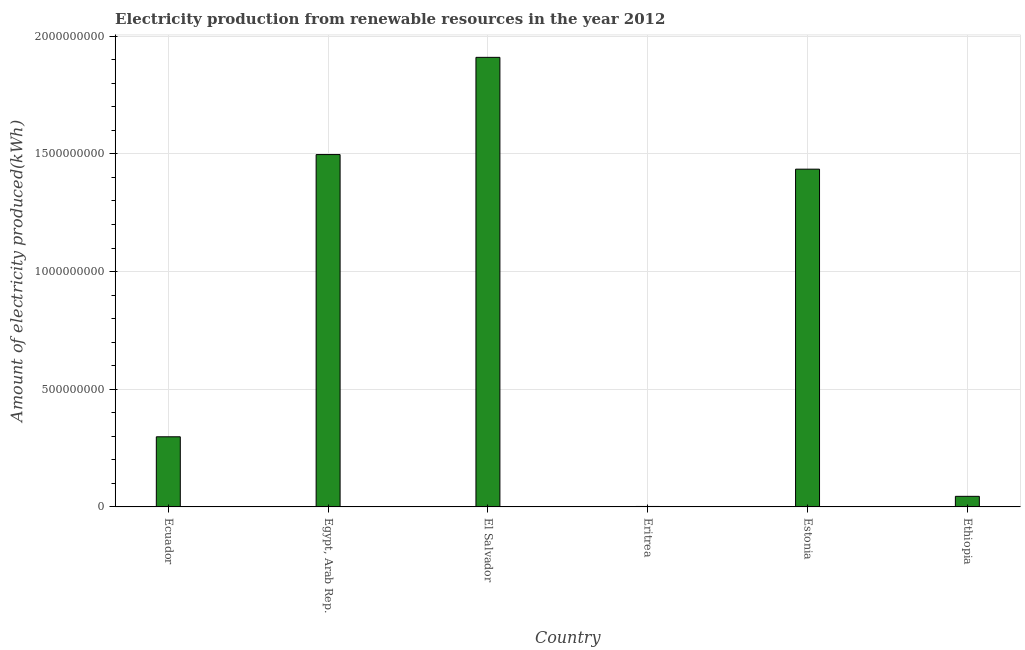Does the graph contain any zero values?
Make the answer very short. No. What is the title of the graph?
Ensure brevity in your answer.  Electricity production from renewable resources in the year 2012. What is the label or title of the Y-axis?
Ensure brevity in your answer.  Amount of electricity produced(kWh). What is the amount of electricity produced in Egypt, Arab Rep.?
Offer a terse response. 1.50e+09. Across all countries, what is the maximum amount of electricity produced?
Your response must be concise. 1.91e+09. In which country was the amount of electricity produced maximum?
Provide a short and direct response. El Salvador. In which country was the amount of electricity produced minimum?
Give a very brief answer. Eritrea. What is the sum of the amount of electricity produced?
Offer a very short reply. 5.19e+09. What is the difference between the amount of electricity produced in El Salvador and Estonia?
Offer a very short reply. 4.75e+08. What is the average amount of electricity produced per country?
Give a very brief answer. 8.64e+08. What is the median amount of electricity produced?
Provide a succinct answer. 8.66e+08. In how many countries, is the amount of electricity produced greater than 1200000000 kWh?
Your answer should be compact. 3. What is the ratio of the amount of electricity produced in El Salvador to that in Eritrea?
Provide a short and direct response. 955. Is the amount of electricity produced in Ecuador less than that in El Salvador?
Make the answer very short. Yes. What is the difference between the highest and the second highest amount of electricity produced?
Make the answer very short. 4.13e+08. Is the sum of the amount of electricity produced in Egypt, Arab Rep. and Ethiopia greater than the maximum amount of electricity produced across all countries?
Provide a short and direct response. No. What is the difference between the highest and the lowest amount of electricity produced?
Give a very brief answer. 1.91e+09. In how many countries, is the amount of electricity produced greater than the average amount of electricity produced taken over all countries?
Offer a very short reply. 3. How many bars are there?
Provide a succinct answer. 6. What is the Amount of electricity produced(kWh) in Ecuador?
Your answer should be very brief. 2.98e+08. What is the Amount of electricity produced(kWh) of Egypt, Arab Rep.?
Offer a very short reply. 1.50e+09. What is the Amount of electricity produced(kWh) of El Salvador?
Offer a very short reply. 1.91e+09. What is the Amount of electricity produced(kWh) of Eritrea?
Your answer should be very brief. 2.00e+06. What is the Amount of electricity produced(kWh) of Estonia?
Ensure brevity in your answer.  1.44e+09. What is the Amount of electricity produced(kWh) in Ethiopia?
Provide a succinct answer. 4.50e+07. What is the difference between the Amount of electricity produced(kWh) in Ecuador and Egypt, Arab Rep.?
Give a very brief answer. -1.20e+09. What is the difference between the Amount of electricity produced(kWh) in Ecuador and El Salvador?
Provide a short and direct response. -1.61e+09. What is the difference between the Amount of electricity produced(kWh) in Ecuador and Eritrea?
Your response must be concise. 2.96e+08. What is the difference between the Amount of electricity produced(kWh) in Ecuador and Estonia?
Give a very brief answer. -1.14e+09. What is the difference between the Amount of electricity produced(kWh) in Ecuador and Ethiopia?
Offer a very short reply. 2.53e+08. What is the difference between the Amount of electricity produced(kWh) in Egypt, Arab Rep. and El Salvador?
Provide a short and direct response. -4.13e+08. What is the difference between the Amount of electricity produced(kWh) in Egypt, Arab Rep. and Eritrea?
Give a very brief answer. 1.50e+09. What is the difference between the Amount of electricity produced(kWh) in Egypt, Arab Rep. and Estonia?
Offer a terse response. 6.20e+07. What is the difference between the Amount of electricity produced(kWh) in Egypt, Arab Rep. and Ethiopia?
Offer a very short reply. 1.45e+09. What is the difference between the Amount of electricity produced(kWh) in El Salvador and Eritrea?
Your answer should be compact. 1.91e+09. What is the difference between the Amount of electricity produced(kWh) in El Salvador and Estonia?
Provide a succinct answer. 4.75e+08. What is the difference between the Amount of electricity produced(kWh) in El Salvador and Ethiopia?
Your answer should be compact. 1.86e+09. What is the difference between the Amount of electricity produced(kWh) in Eritrea and Estonia?
Keep it short and to the point. -1.43e+09. What is the difference between the Amount of electricity produced(kWh) in Eritrea and Ethiopia?
Provide a succinct answer. -4.30e+07. What is the difference between the Amount of electricity produced(kWh) in Estonia and Ethiopia?
Make the answer very short. 1.39e+09. What is the ratio of the Amount of electricity produced(kWh) in Ecuador to that in Egypt, Arab Rep.?
Ensure brevity in your answer.  0.2. What is the ratio of the Amount of electricity produced(kWh) in Ecuador to that in El Salvador?
Your answer should be very brief. 0.16. What is the ratio of the Amount of electricity produced(kWh) in Ecuador to that in Eritrea?
Offer a very short reply. 149. What is the ratio of the Amount of electricity produced(kWh) in Ecuador to that in Estonia?
Keep it short and to the point. 0.21. What is the ratio of the Amount of electricity produced(kWh) in Ecuador to that in Ethiopia?
Give a very brief answer. 6.62. What is the ratio of the Amount of electricity produced(kWh) in Egypt, Arab Rep. to that in El Salvador?
Your answer should be very brief. 0.78. What is the ratio of the Amount of electricity produced(kWh) in Egypt, Arab Rep. to that in Eritrea?
Provide a short and direct response. 748.5. What is the ratio of the Amount of electricity produced(kWh) in Egypt, Arab Rep. to that in Estonia?
Ensure brevity in your answer.  1.04. What is the ratio of the Amount of electricity produced(kWh) in Egypt, Arab Rep. to that in Ethiopia?
Your response must be concise. 33.27. What is the ratio of the Amount of electricity produced(kWh) in El Salvador to that in Eritrea?
Provide a succinct answer. 955. What is the ratio of the Amount of electricity produced(kWh) in El Salvador to that in Estonia?
Your answer should be compact. 1.33. What is the ratio of the Amount of electricity produced(kWh) in El Salvador to that in Ethiopia?
Your answer should be very brief. 42.44. What is the ratio of the Amount of electricity produced(kWh) in Eritrea to that in Estonia?
Give a very brief answer. 0. What is the ratio of the Amount of electricity produced(kWh) in Eritrea to that in Ethiopia?
Offer a very short reply. 0.04. What is the ratio of the Amount of electricity produced(kWh) in Estonia to that in Ethiopia?
Make the answer very short. 31.89. 